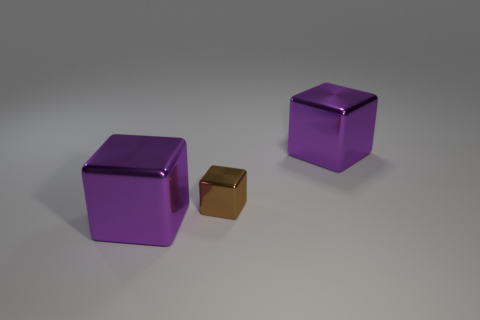Does the large metallic cube in front of the tiny brown cube have the same color as the thing behind the brown cube?
Offer a very short reply. Yes. How many rubber objects are either brown blocks or large cubes?
Your response must be concise. 0. There is a shiny object that is on the left side of the small brown metal thing; what number of brown objects are to the left of it?
Make the answer very short. 0. What number of other purple objects have the same material as the tiny thing?
Offer a terse response. 2. How many large things are either brown cubes or purple metallic cubes?
Offer a terse response. 2. There is a brown shiny object that is to the right of the big metallic object that is left of the large shiny thing that is on the right side of the brown cube; what size is it?
Your answer should be compact. Small. What is the tiny cube made of?
Make the answer very short. Metal. There is a big metal object that is right of the purple metallic object that is in front of the small metal thing; is there a large purple shiny thing in front of it?
Provide a succinct answer. Yes. The small object has what color?
Your response must be concise. Brown. There is a tiny thing; are there any purple objects in front of it?
Provide a short and direct response. Yes. 